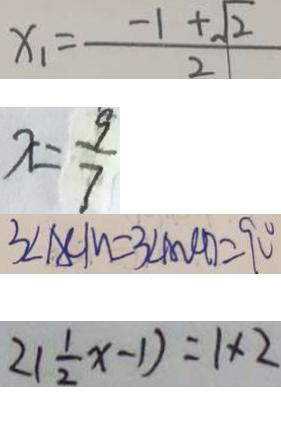Convert formula to latex. <formula><loc_0><loc_0><loc_500><loc_500>x _ { 1 } = \frac { - 1 + \sqrt { 2 } } { 2 } 
 x = \frac { 9 } { 7 } 
 3 \angle A C M = 3 \angle A O C D = 9 0 ^ { \circ } 
 2 ( \frac { 1 } { 2 } x - 1 ) = 1 \times 2</formula> 